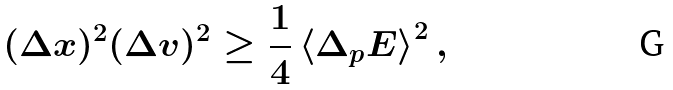<formula> <loc_0><loc_0><loc_500><loc_500>( \Delta x ) ^ { 2 } ( \Delta v ) ^ { 2 } \geq \frac { 1 } { 4 } \left \langle \Delta _ { p } E \right \rangle ^ { 2 } ,</formula> 